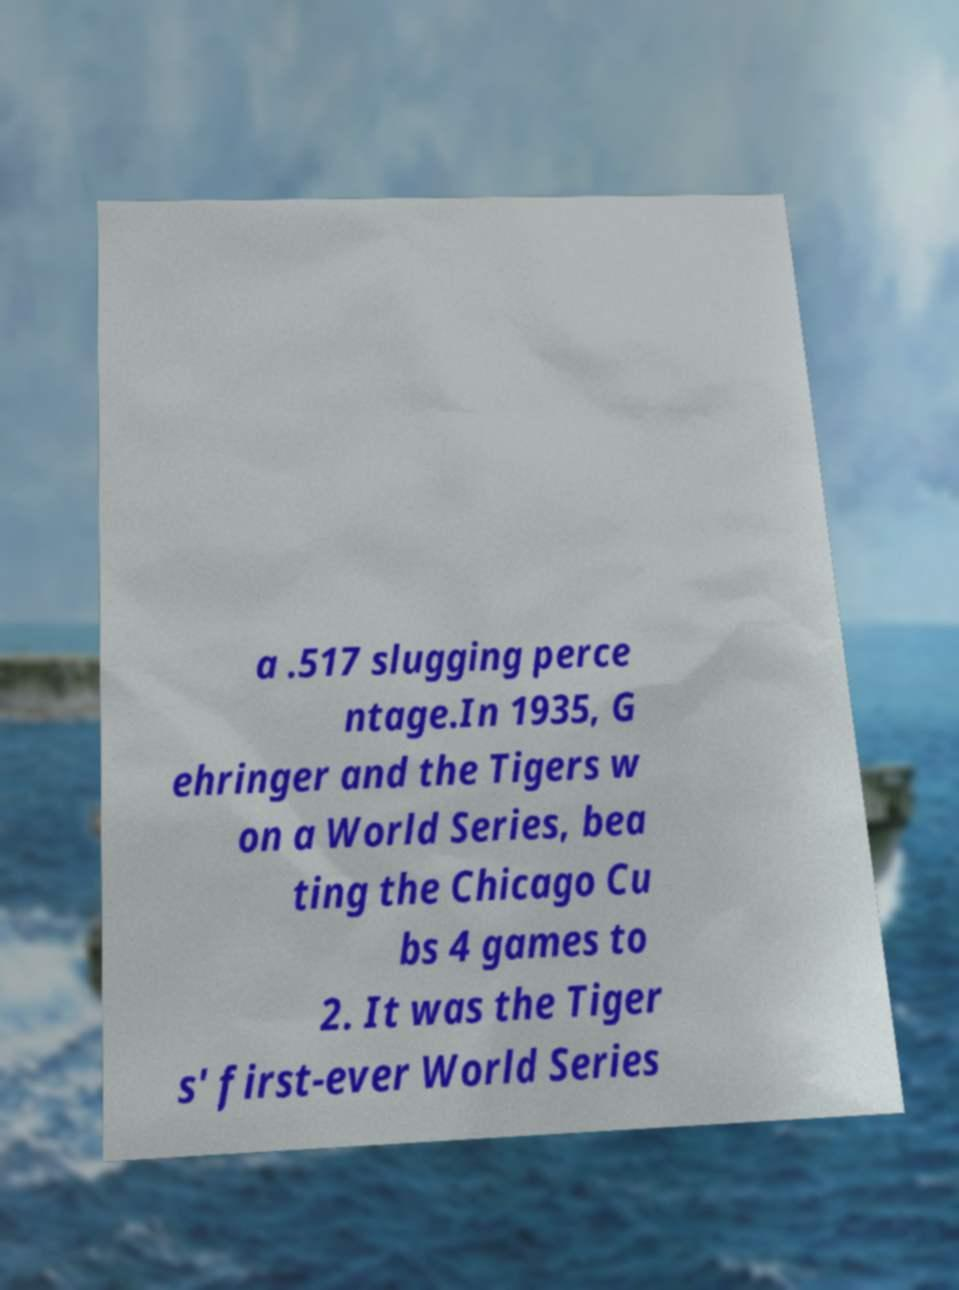Can you accurately transcribe the text from the provided image for me? a .517 slugging perce ntage.In 1935, G ehringer and the Tigers w on a World Series, bea ting the Chicago Cu bs 4 games to 2. It was the Tiger s' first-ever World Series 